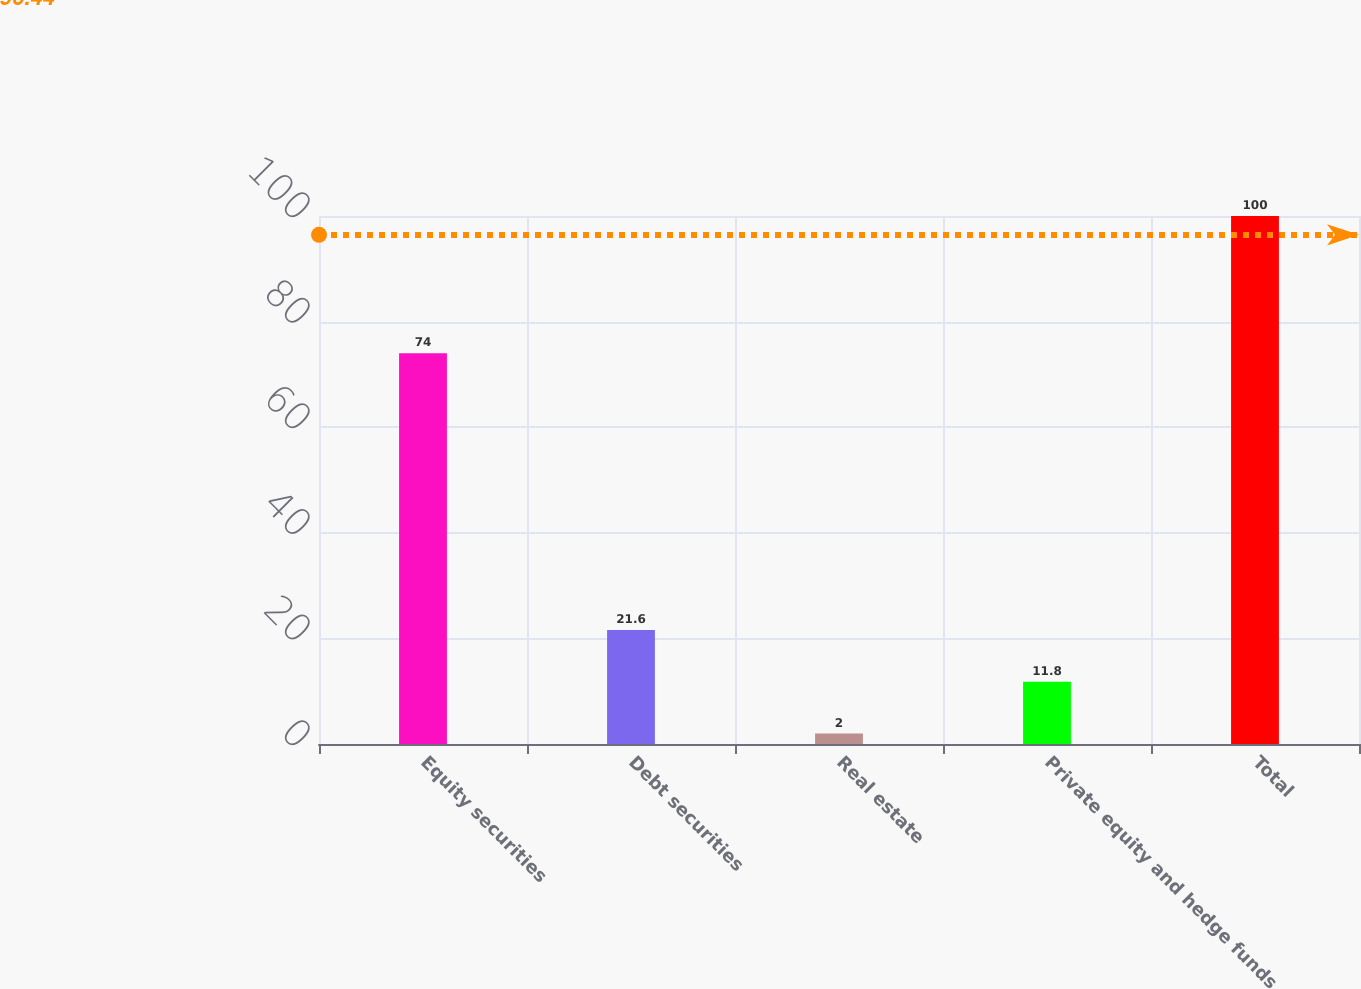Convert chart. <chart><loc_0><loc_0><loc_500><loc_500><bar_chart><fcel>Equity securities<fcel>Debt securities<fcel>Real estate<fcel>Private equity and hedge funds<fcel>Total<nl><fcel>74<fcel>21.6<fcel>2<fcel>11.8<fcel>100<nl></chart> 